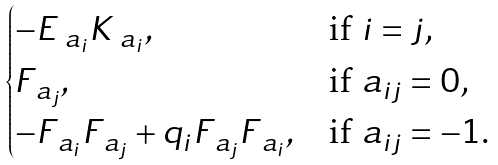Convert formula to latex. <formula><loc_0><loc_0><loc_500><loc_500>\begin{cases} - E _ { \ a _ { i } } K _ { \ a _ { i } } , & \text {if $i=j$,} \\ F _ { \ a _ { j } } , & \text {if $a_{ij}=0$,} \\ - F _ { \ a _ { i } } F _ { \ a _ { j } } + q _ { i } F _ { \ a _ { j } } F _ { \ a _ { i } } , & \text {if $a_{ij}=-1$.} \end{cases}</formula> 